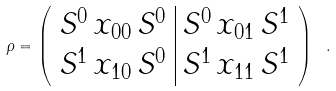Convert formula to latex. <formula><loc_0><loc_0><loc_500><loc_500>\rho = \left ( \begin{array} { c | c } S ^ { 0 } \, x _ { 0 0 } \, S ^ { 0 } & S ^ { 0 } \, x _ { 0 1 } \, S ^ { 1 } \\ S ^ { 1 } \, x _ { 1 0 } \, S ^ { 0 } & S ^ { 1 } \, x _ { 1 1 } \, S ^ { 1 } \end{array} \right ) \ .</formula> 